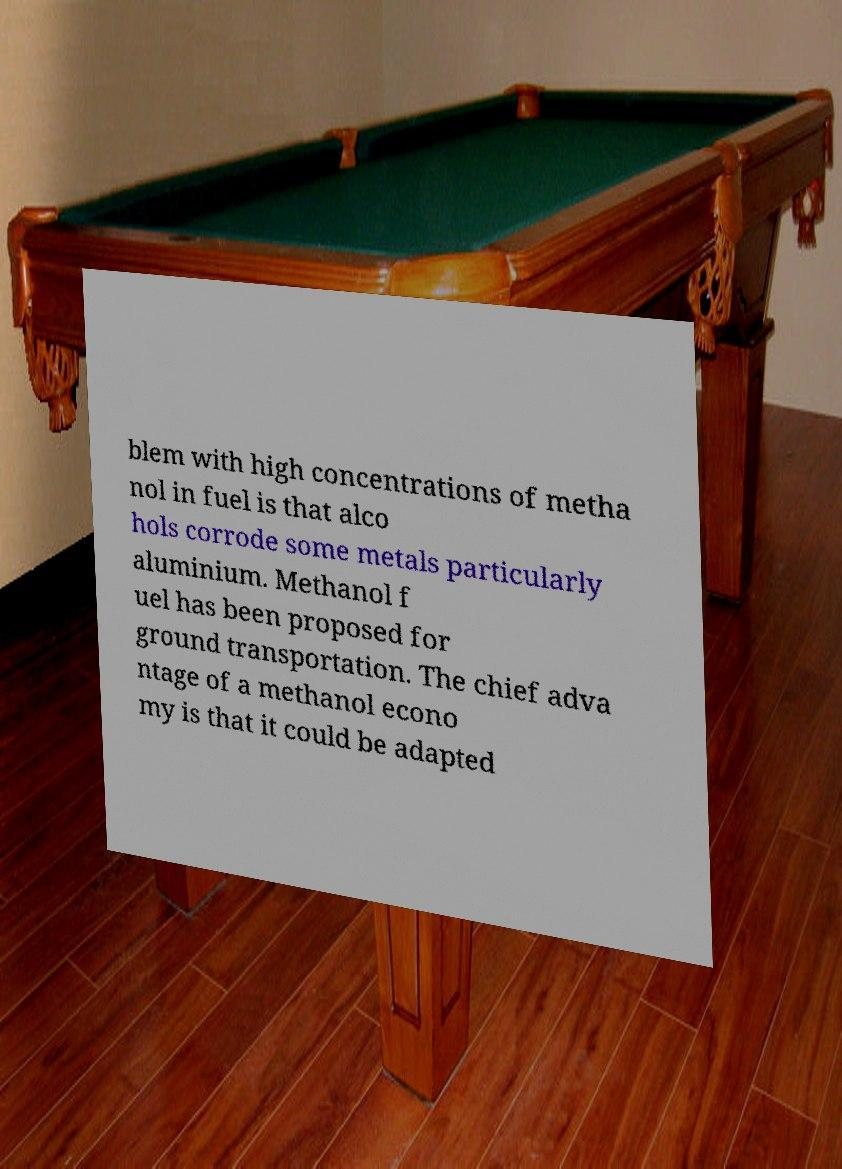Can you accurately transcribe the text from the provided image for me? blem with high concentrations of metha nol in fuel is that alco hols corrode some metals particularly aluminium. Methanol f uel has been proposed for ground transportation. The chief adva ntage of a methanol econo my is that it could be adapted 